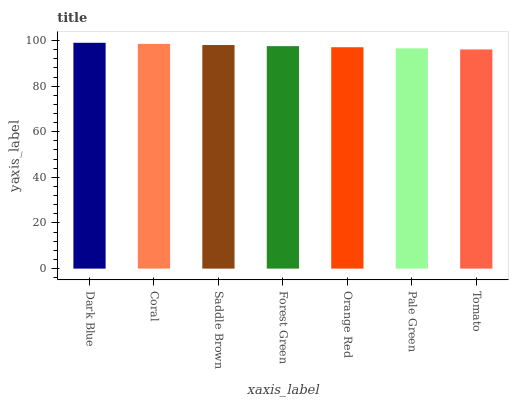Is Tomato the minimum?
Answer yes or no. Yes. Is Dark Blue the maximum?
Answer yes or no. Yes. Is Coral the minimum?
Answer yes or no. No. Is Coral the maximum?
Answer yes or no. No. Is Dark Blue greater than Coral?
Answer yes or no. Yes. Is Coral less than Dark Blue?
Answer yes or no. Yes. Is Coral greater than Dark Blue?
Answer yes or no. No. Is Dark Blue less than Coral?
Answer yes or no. No. Is Forest Green the high median?
Answer yes or no. Yes. Is Forest Green the low median?
Answer yes or no. Yes. Is Tomato the high median?
Answer yes or no. No. Is Tomato the low median?
Answer yes or no. No. 